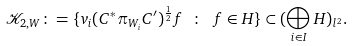Convert formula to latex. <formula><loc_0><loc_0><loc_500><loc_500>\mathcal { K } _ { 2 , W } \colon = \{ v _ { i } ( C ^ { * } \pi _ { W _ { i } } C ^ { \prime } ) ^ { \frac { 1 } { 2 } } f \ \colon \ f \in H \} \subset ( \bigoplus _ { i \in I } H ) _ { l ^ { 2 } } .</formula> 